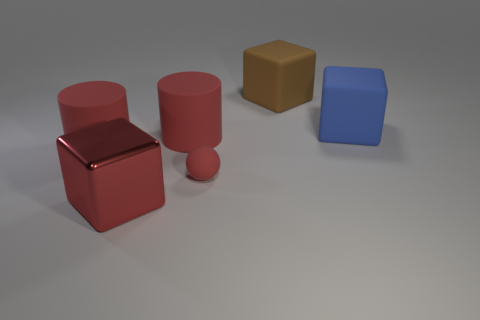Add 4 tiny cyan rubber cylinders. How many objects exist? 10 Subtract all cylinders. How many objects are left? 4 Subtract 1 brown blocks. How many objects are left? 5 Subtract all cubes. Subtract all blocks. How many objects are left? 0 Add 3 brown objects. How many brown objects are left? 4 Add 3 small objects. How many small objects exist? 4 